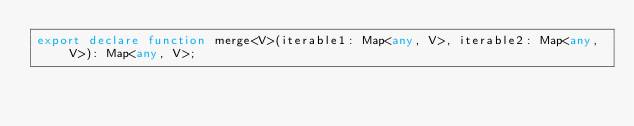<code> <loc_0><loc_0><loc_500><loc_500><_TypeScript_>export declare function merge<V>(iterable1: Map<any, V>, iterable2: Map<any, V>): Map<any, V>;
</code> 